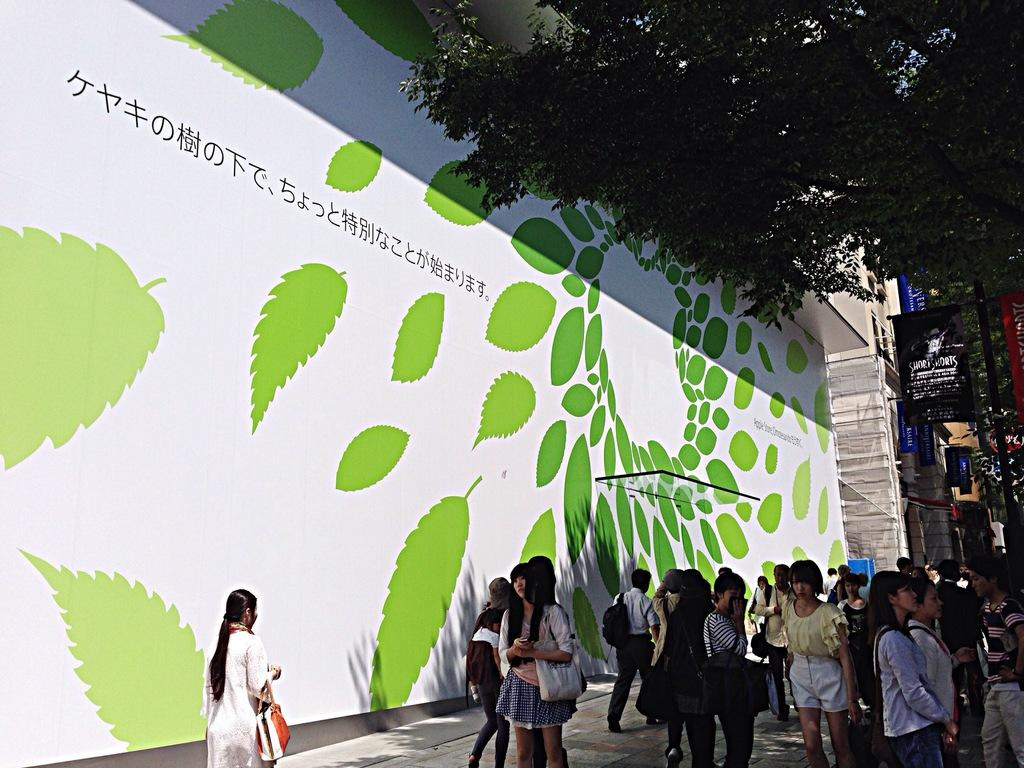What are the people in the image doing? The people in the image are walking on a footpath. What can be seen in the background of the image? There is a poster in the background of the image. What is depicted on the poster? The poster contains leaves and text. Where is the tree located in the image? The tree is visible in the top right corner of the image. How many people are wearing mittens in the image? There are no mittens present in the image. What type of police presence can be seen in the image? There is no police presence in the image. 